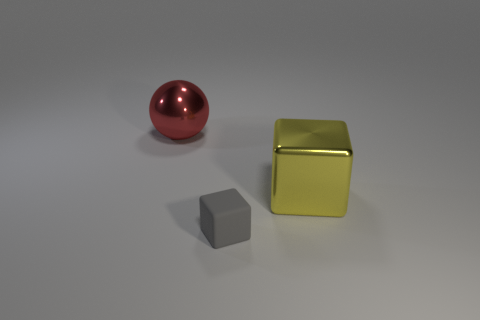Add 2 large purple spheres. How many objects exist? 5 Subtract all blocks. How many objects are left? 1 Add 3 small matte things. How many small matte things exist? 4 Subtract 0 cyan spheres. How many objects are left? 3 Subtract all metal cubes. Subtract all tiny matte things. How many objects are left? 1 Add 1 small matte things. How many small matte things are left? 2 